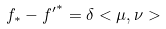Convert formula to latex. <formula><loc_0><loc_0><loc_500><loc_500>f _ { * } - { f ^ { \prime } } ^ { * } = \delta < \mu , \nu ></formula> 